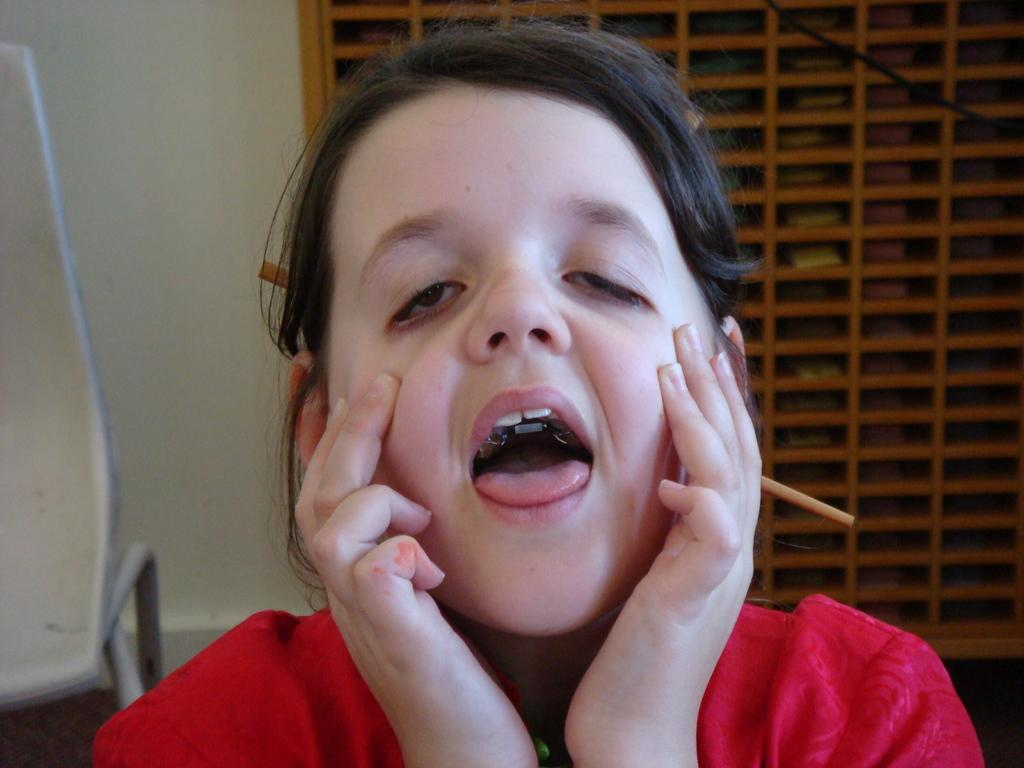Who is the main subject in the image? There is a girl in the image. What can be seen in the background of the image? There is a wall, a chair, and an object in the background of the image. What type of line is being used for arithmetic in the image? There is no line or arithmetic present in the image; it features a girl and objects in the background. 